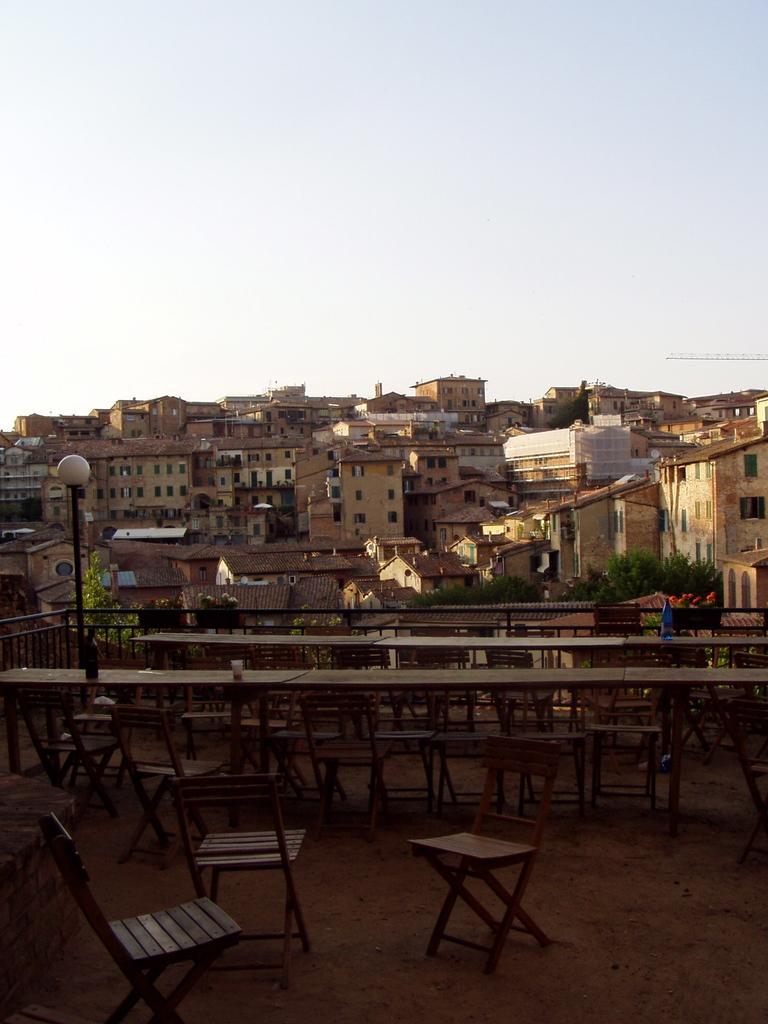How would you summarize this image in a sentence or two? In this picture we can see few chairs, tables, metal rods and a light, in the background we can see few buildings and trees. 